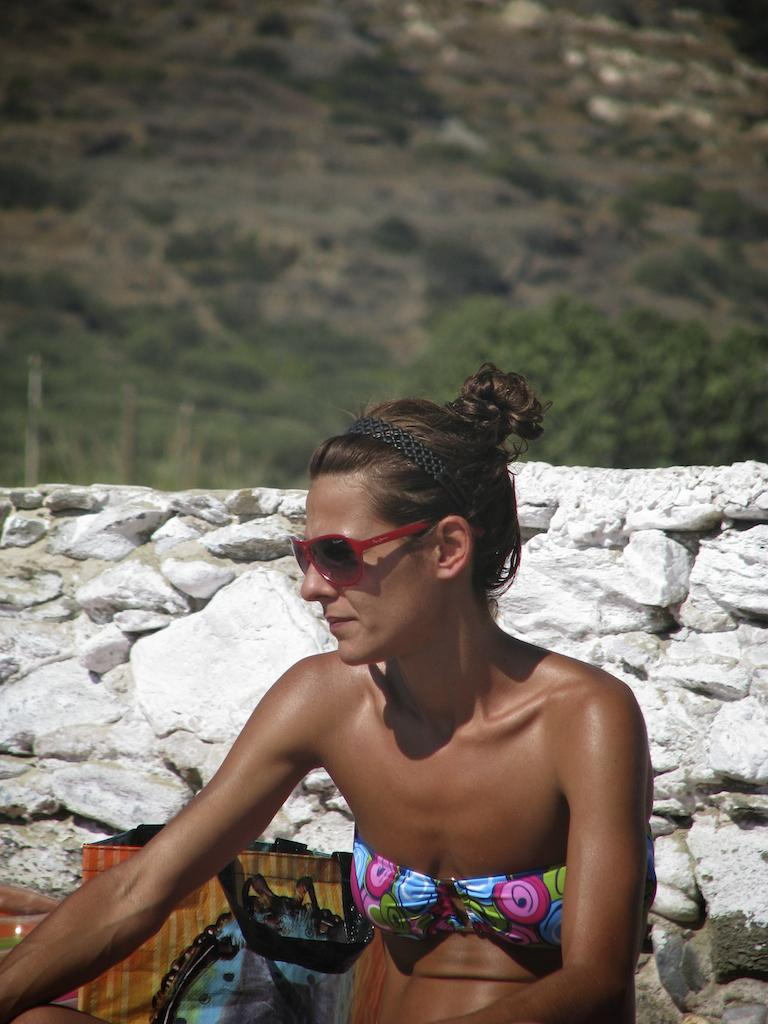Who is the main subject in the image? There is a lady in the image. What object is located behind the lady? There is a bag behind the lady. What is behind the bag in the image? There is a wall behind the bag. What can be seen in the distance in the image? There is a mountain visible in the background. What type of calculator is the lady using in the image? There is no calculator present in the image. How does the lady show care for the environment in the image? The image does not provide information about the lady's actions or intentions regarding the environment. 